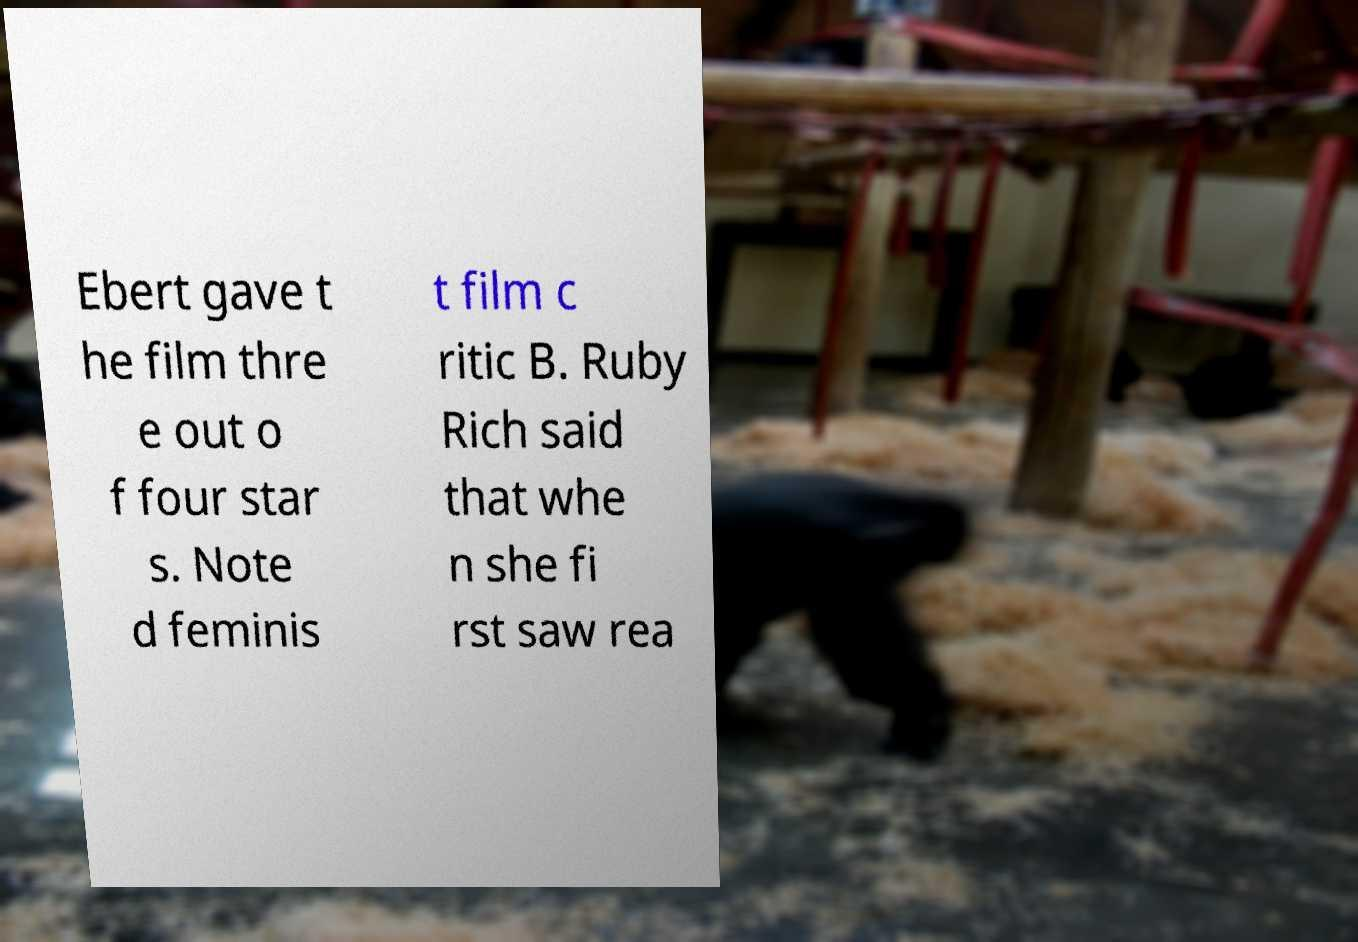For documentation purposes, I need the text within this image transcribed. Could you provide that? Ebert gave t he film thre e out o f four star s. Note d feminis t film c ritic B. Ruby Rich said that whe n she fi rst saw rea 